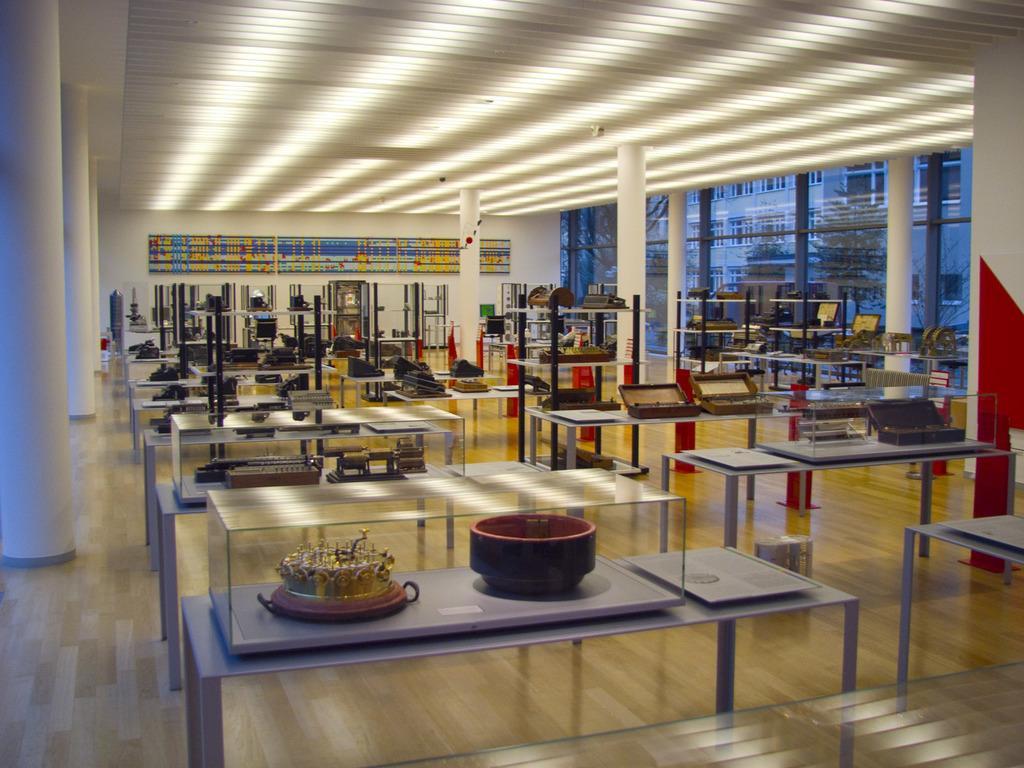Please provide a concise description of this image. A room in a museum is shown in the picture. The artifacts are arranged on tables. The pillars are very tall and painted in white. There is a glass frame work on one side. Through which one can see outside environment. 